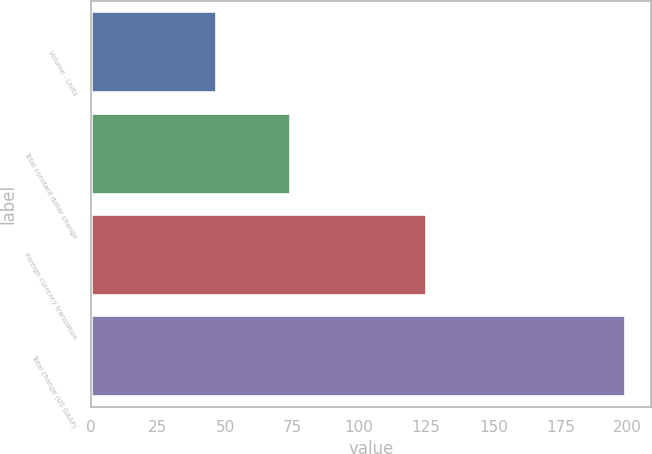Convert chart. <chart><loc_0><loc_0><loc_500><loc_500><bar_chart><fcel>Volume - Units<fcel>Total constant dollar change<fcel>Foreign currency translation<fcel>Total change (US GAAP)<nl><fcel>46.8<fcel>74.1<fcel>124.9<fcel>199<nl></chart> 